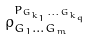Convert formula to latex. <formula><loc_0><loc_0><loc_500><loc_500>\rho _ { G _ { 1 } \dots G _ { m } } ^ { P _ { G _ { k _ { 1 } } \dots G _ { k _ { q } } } }</formula> 